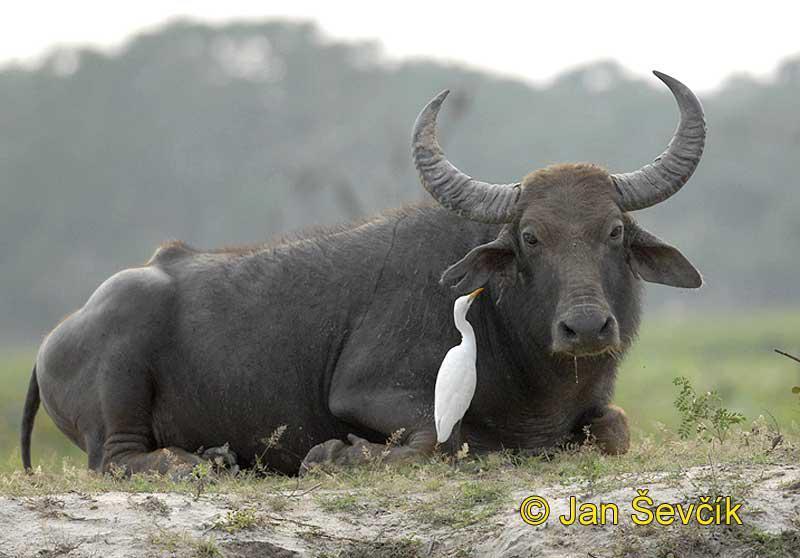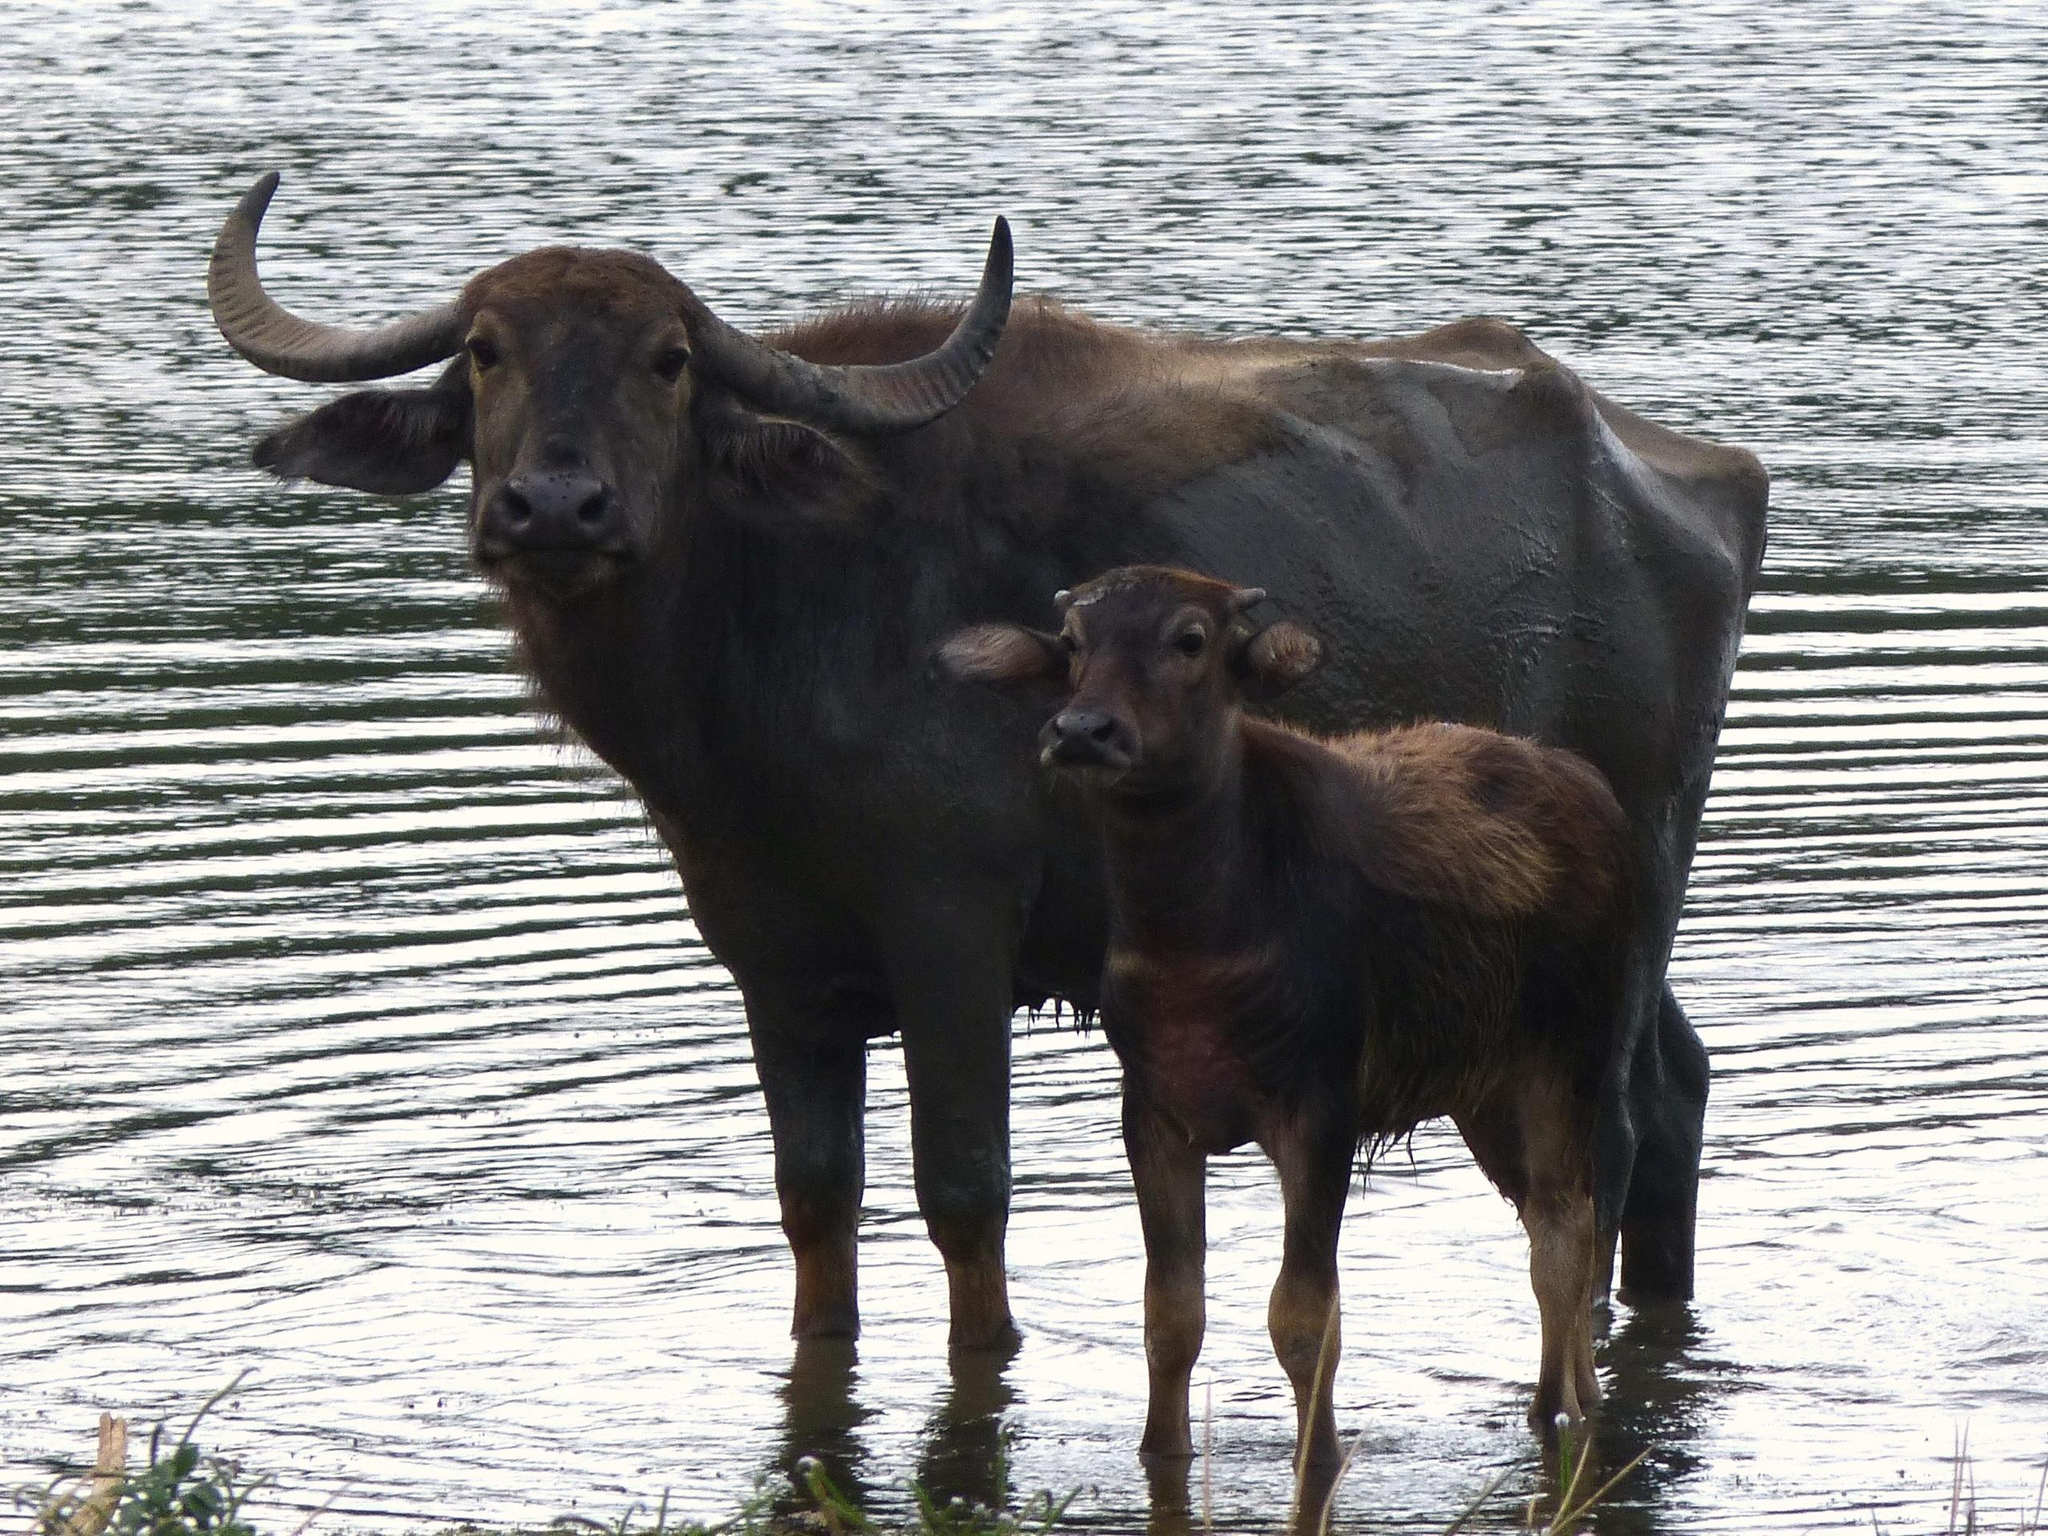The first image is the image on the left, the second image is the image on the right. For the images shown, is this caption "An area of water is present in one image of water buffalo." true? Answer yes or no. Yes. 